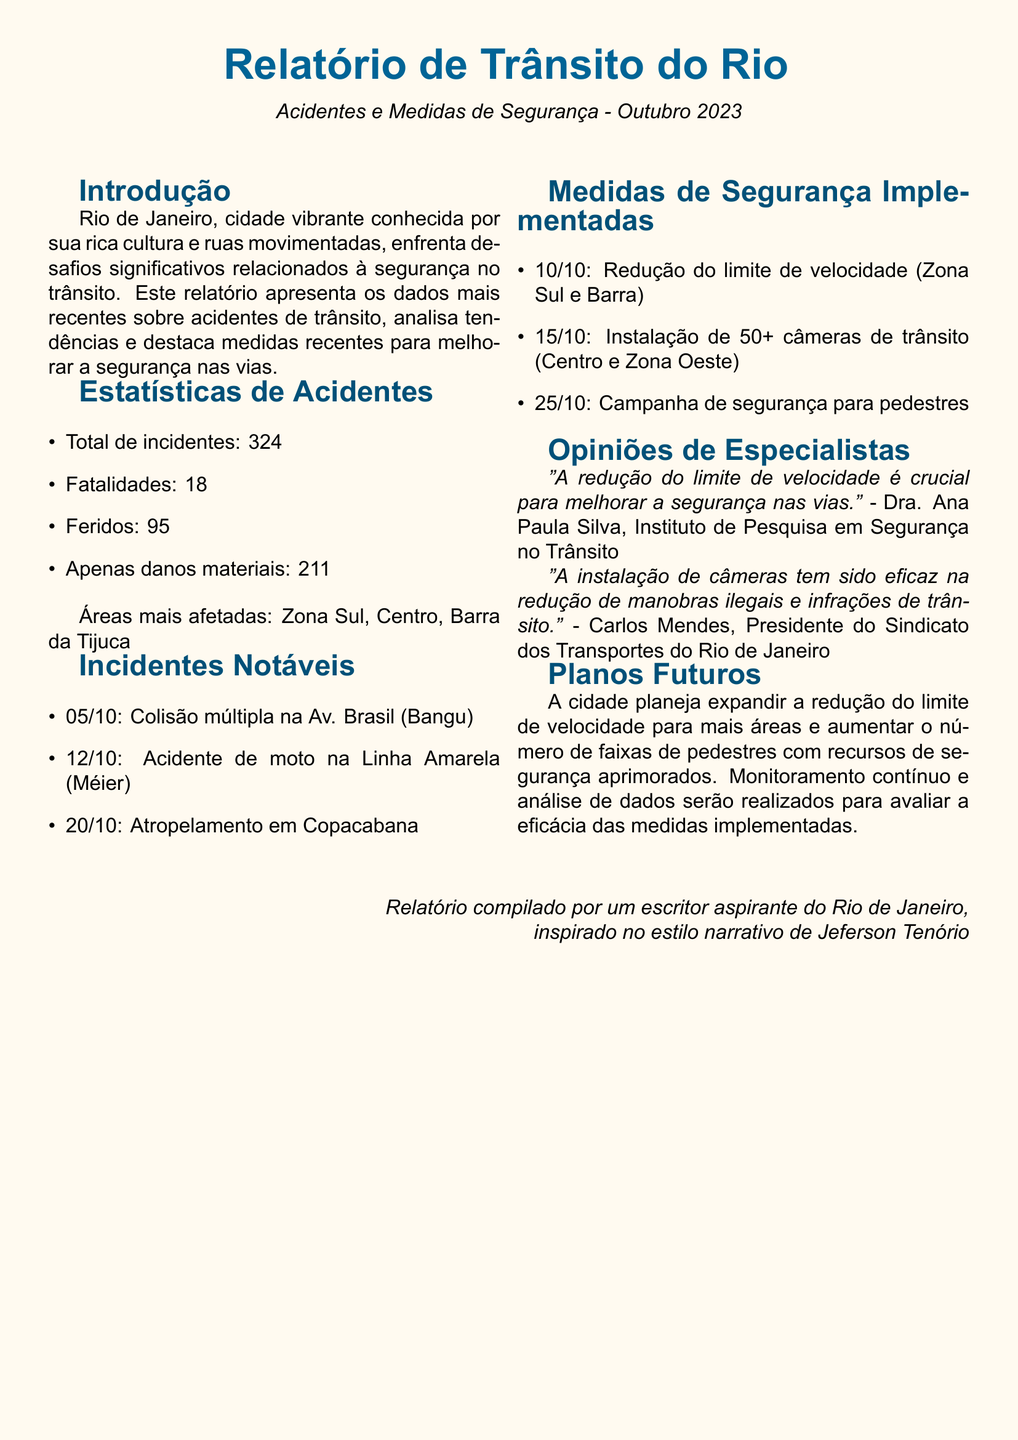What is the total number of incidents reported? The total number of incidents is explicitly mentioned in the statistics section of the report.
Answer: 324 How many fatalities occurred in October 2023? The number of fatalities is indicated in the statistics section as part of the accidents data.
Answer: 18 What area had a notable multiple collision incident on October 5th? The specific area of the incident on October 5th is provided in the incidents section.
Answer: Av. Brasil (Bangu) When were the cameras installed? The date of installation of the traffic cameras is specified in the measures section.
Answer: 15/10 Who commented on the effectiveness of camera installation? The name of the individual providing commentary on the camera installation is included in the expert opinions section.
Answer: Carlos Mendes Which area is associated with the newly implemented speed limit reductions? The specific areas for the speed limit reductions are mentioned within the report, highlighting the locations impacted.
Answer: Zona Sul e Barra What is the planned future action regarding speed limits? The report outlines planned future actions in relation to speed limits, indicating an expansion approach.
Answer: Expand reduction How many pedestrians were harmed according to the report? The number of injured individuals is included in the statistics section, focusing on those who suffered injuries.
Answer: 95 What is the primary focus of the report's introduction? The introduction emphasizes the central issue faced by Rio de Janeiro, as detailed in the beginning of the document.
Answer: Segurança no trânsito Which campaign was initiated on October 25th? The specific campaign date and title are presented in the safety measures section of the report.
Answer: Campanha de segurança para pedestres 